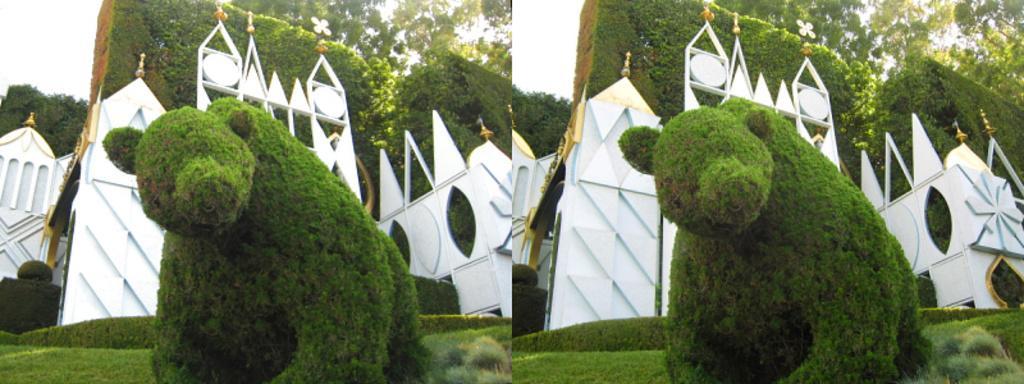Describe this image in one or two sentences. It is a collage picture. In this image, we can see animal shaped tree, grass and some arches. Background there is a sky. 